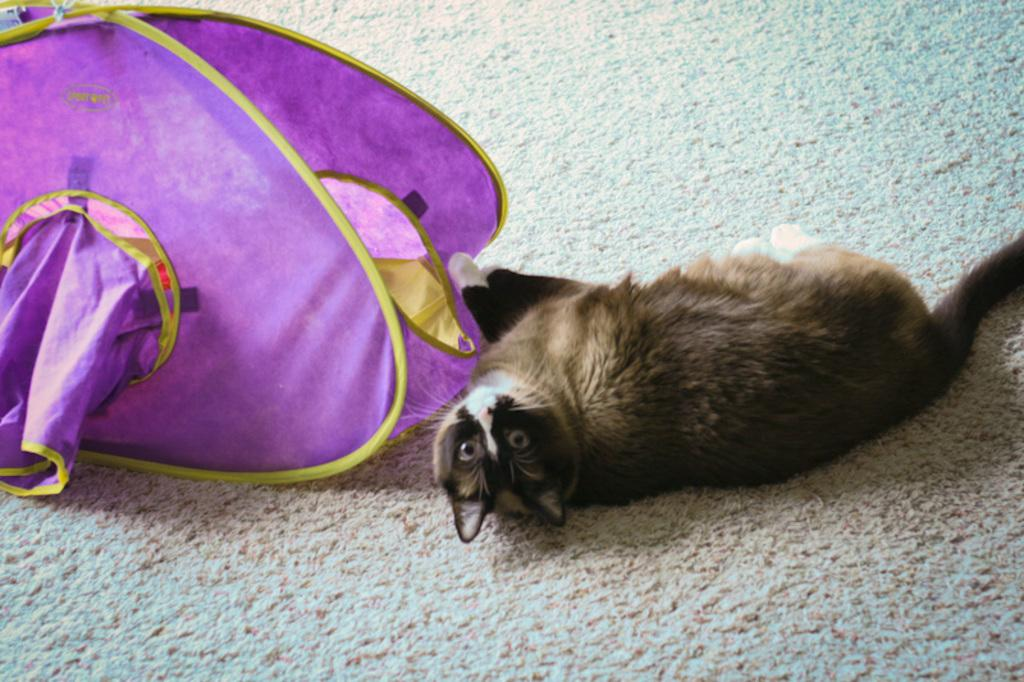What type of animal is present in the image? There is a cat in the image. What is the cat doing in the image? The cat is laying on a mat. Is there any shelter for the cat in the image? Yes, there is a cat house in the image. What type of book is the cat reading in the image? There is no book present in the image, and the cat is not reading. 